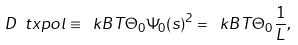Convert formula to latex. <formula><loc_0><loc_0><loc_500><loc_500>D _ { \ } t x { p o l } \equiv \ k B T \Theta _ { 0 } \Psi _ { 0 } ( s ) ^ { 2 } = \ k B T \Theta _ { 0 } \frac { 1 } { L } ,</formula> 